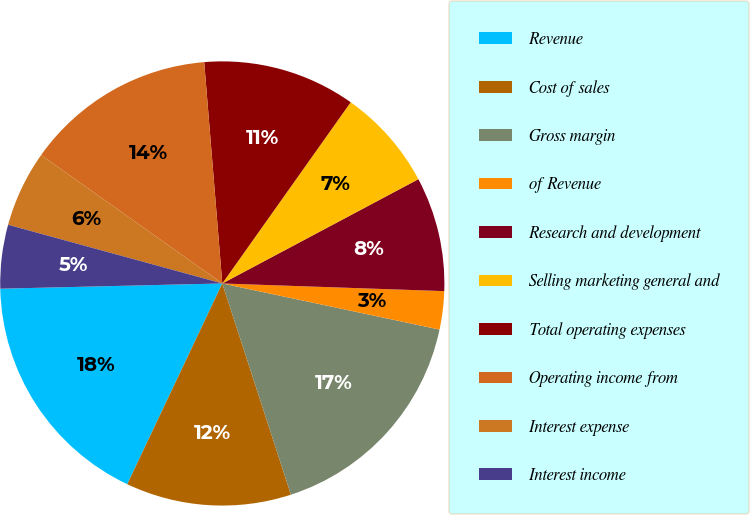Convert chart to OTSL. <chart><loc_0><loc_0><loc_500><loc_500><pie_chart><fcel>Revenue<fcel>Cost of sales<fcel>Gross margin<fcel>of Revenue<fcel>Research and development<fcel>Selling marketing general and<fcel>Total operating expenses<fcel>Operating income from<fcel>Interest expense<fcel>Interest income<nl><fcel>17.59%<fcel>12.04%<fcel>16.67%<fcel>2.78%<fcel>8.33%<fcel>7.41%<fcel>11.11%<fcel>13.89%<fcel>5.56%<fcel>4.63%<nl></chart> 